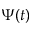<formula> <loc_0><loc_0><loc_500><loc_500>\Psi ( t )</formula> 